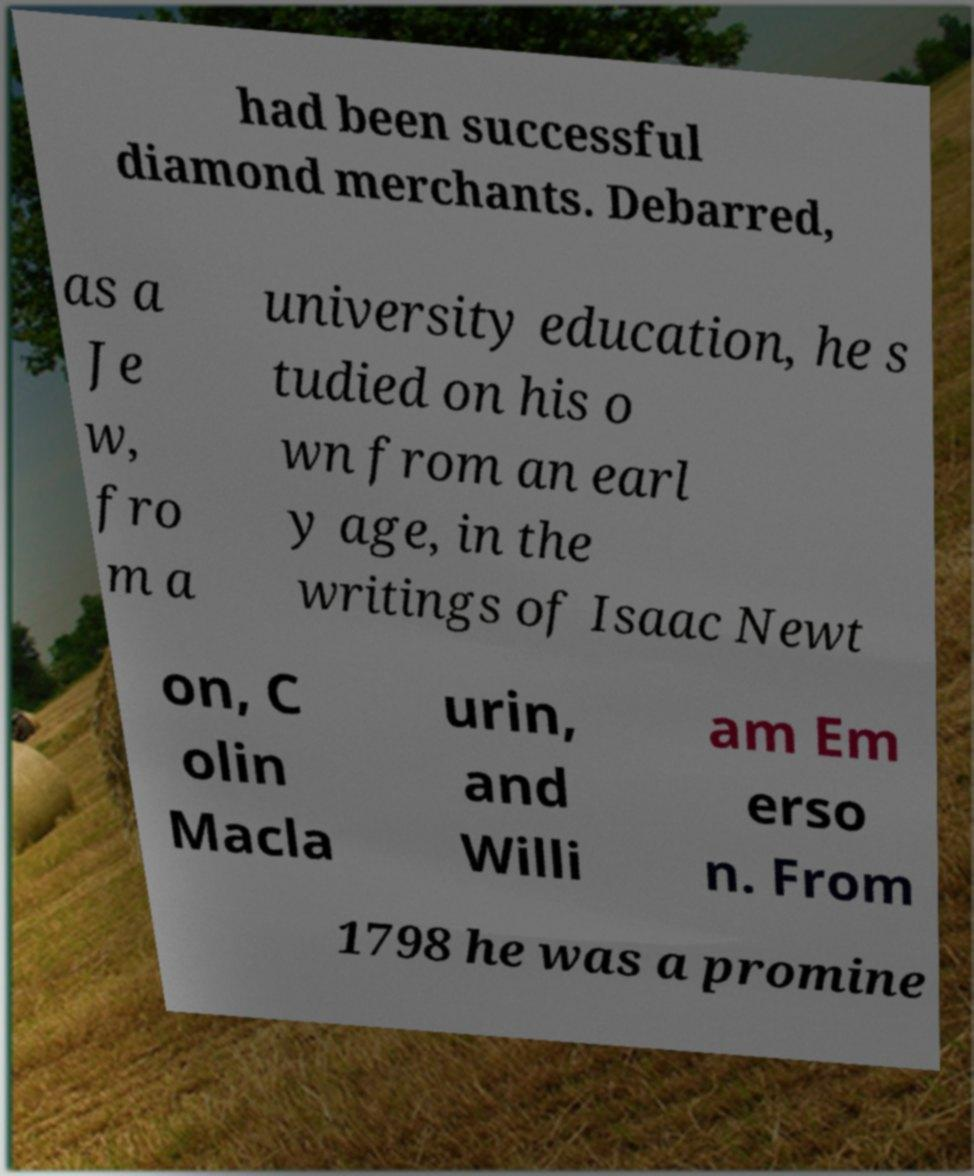I need the written content from this picture converted into text. Can you do that? had been successful diamond merchants. Debarred, as a Je w, fro m a university education, he s tudied on his o wn from an earl y age, in the writings of Isaac Newt on, C olin Macla urin, and Willi am Em erso n. From 1798 he was a promine 